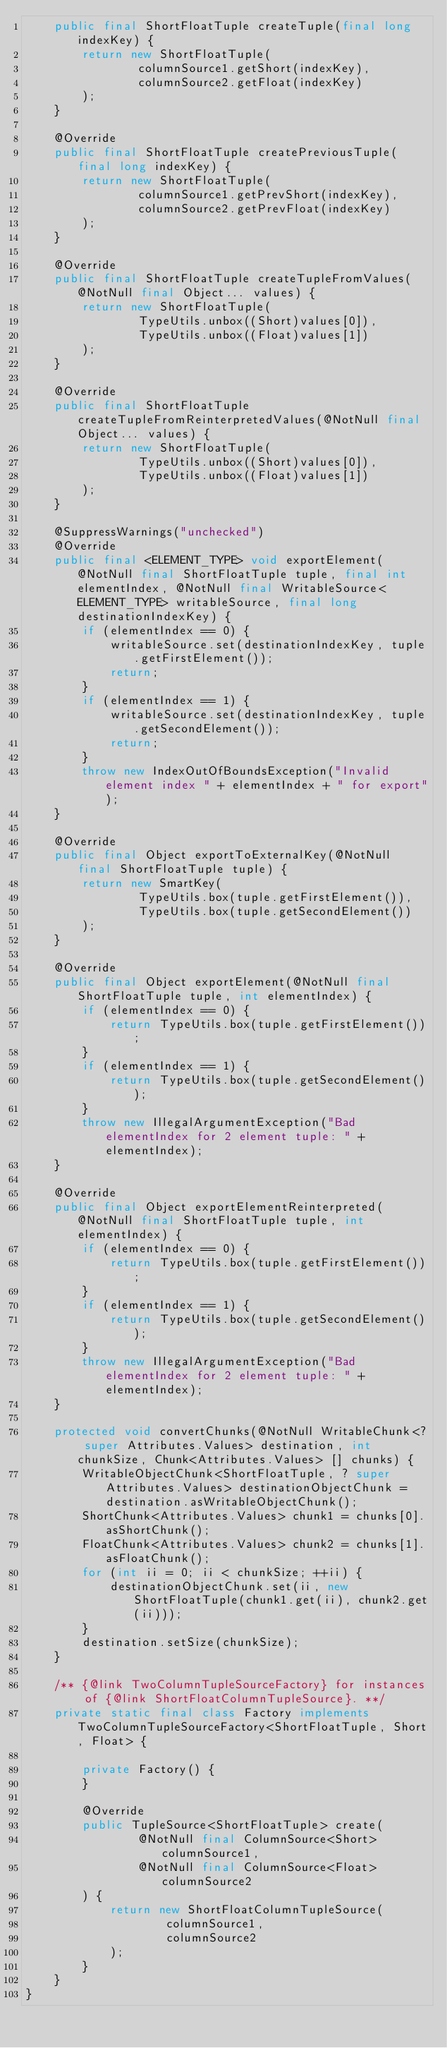Convert code to text. <code><loc_0><loc_0><loc_500><loc_500><_Java_>    public final ShortFloatTuple createTuple(final long indexKey) {
        return new ShortFloatTuple(
                columnSource1.getShort(indexKey),
                columnSource2.getFloat(indexKey)
        );
    }

    @Override
    public final ShortFloatTuple createPreviousTuple(final long indexKey) {
        return new ShortFloatTuple(
                columnSource1.getPrevShort(indexKey),
                columnSource2.getPrevFloat(indexKey)
        );
    }

    @Override
    public final ShortFloatTuple createTupleFromValues(@NotNull final Object... values) {
        return new ShortFloatTuple(
                TypeUtils.unbox((Short)values[0]),
                TypeUtils.unbox((Float)values[1])
        );
    }

    @Override
    public final ShortFloatTuple createTupleFromReinterpretedValues(@NotNull final Object... values) {
        return new ShortFloatTuple(
                TypeUtils.unbox((Short)values[0]),
                TypeUtils.unbox((Float)values[1])
        );
    }

    @SuppressWarnings("unchecked")
    @Override
    public final <ELEMENT_TYPE> void exportElement(@NotNull final ShortFloatTuple tuple, final int elementIndex, @NotNull final WritableSource<ELEMENT_TYPE> writableSource, final long destinationIndexKey) {
        if (elementIndex == 0) {
            writableSource.set(destinationIndexKey, tuple.getFirstElement());
            return;
        }
        if (elementIndex == 1) {
            writableSource.set(destinationIndexKey, tuple.getSecondElement());
            return;
        }
        throw new IndexOutOfBoundsException("Invalid element index " + elementIndex + " for export");
    }

    @Override
    public final Object exportToExternalKey(@NotNull final ShortFloatTuple tuple) {
        return new SmartKey(
                TypeUtils.box(tuple.getFirstElement()),
                TypeUtils.box(tuple.getSecondElement())
        );
    }

    @Override
    public final Object exportElement(@NotNull final ShortFloatTuple tuple, int elementIndex) {
        if (elementIndex == 0) {
            return TypeUtils.box(tuple.getFirstElement());
        }
        if (elementIndex == 1) {
            return TypeUtils.box(tuple.getSecondElement());
        }
        throw new IllegalArgumentException("Bad elementIndex for 2 element tuple: " + elementIndex);
    }

    @Override
    public final Object exportElementReinterpreted(@NotNull final ShortFloatTuple tuple, int elementIndex) {
        if (elementIndex == 0) {
            return TypeUtils.box(tuple.getFirstElement());
        }
        if (elementIndex == 1) {
            return TypeUtils.box(tuple.getSecondElement());
        }
        throw new IllegalArgumentException("Bad elementIndex for 2 element tuple: " + elementIndex);
    }

    protected void convertChunks(@NotNull WritableChunk<? super Attributes.Values> destination, int chunkSize, Chunk<Attributes.Values> [] chunks) {
        WritableObjectChunk<ShortFloatTuple, ? super Attributes.Values> destinationObjectChunk = destination.asWritableObjectChunk();
        ShortChunk<Attributes.Values> chunk1 = chunks[0].asShortChunk();
        FloatChunk<Attributes.Values> chunk2 = chunks[1].asFloatChunk();
        for (int ii = 0; ii < chunkSize; ++ii) {
            destinationObjectChunk.set(ii, new ShortFloatTuple(chunk1.get(ii), chunk2.get(ii)));
        }
        destination.setSize(chunkSize);
    }

    /** {@link TwoColumnTupleSourceFactory} for instances of {@link ShortFloatColumnTupleSource}. **/
    private static final class Factory implements TwoColumnTupleSourceFactory<ShortFloatTuple, Short, Float> {

        private Factory() {
        }

        @Override
        public TupleSource<ShortFloatTuple> create(
                @NotNull final ColumnSource<Short> columnSource1,
                @NotNull final ColumnSource<Float> columnSource2
        ) {
            return new ShortFloatColumnTupleSource(
                    columnSource1,
                    columnSource2
            );
        }
    }
}
</code> 